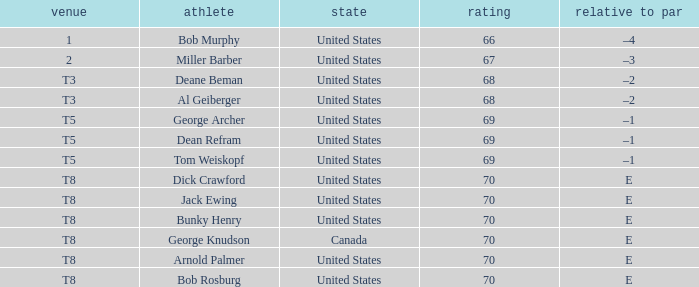When bunky henry of the united states got more than 67 and his to par was e, what was his ranking? T8. 